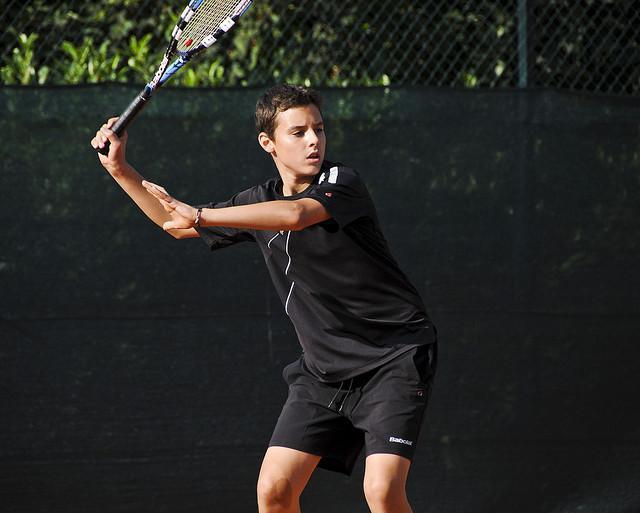How many bracelets is the player wearing?
Give a very brief answer. 1. How many of the bikes are blue?
Give a very brief answer. 0. 